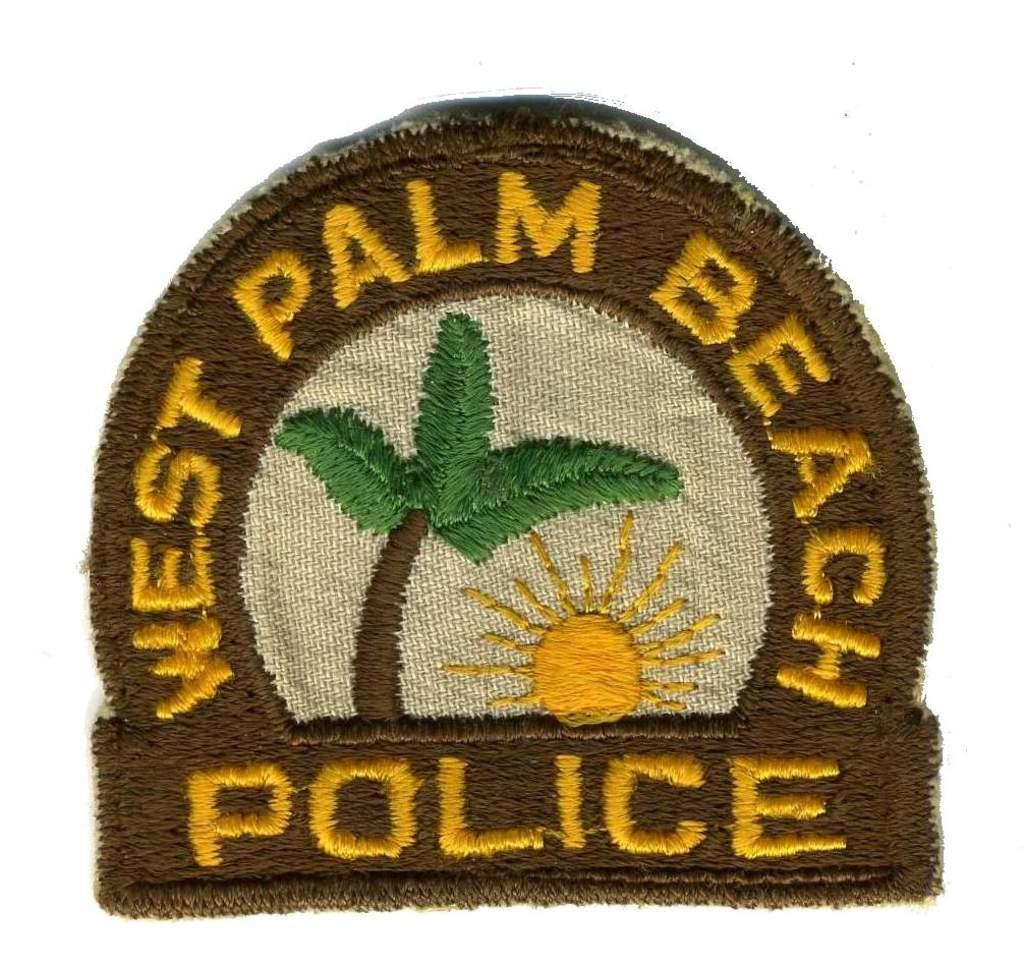Provide a one-sentence caption for the provided image. West Palm Beach police patch that can be sewn on to anything. 